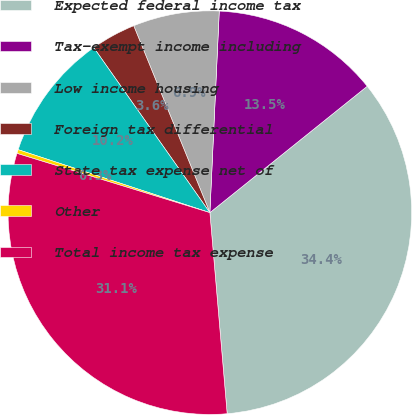<chart> <loc_0><loc_0><loc_500><loc_500><pie_chart><fcel>Expected federal income tax<fcel>Tax-exempt income including<fcel>Low income housing<fcel>Foreign tax differential<fcel>State tax expense net of<fcel>Other<fcel>Total income tax expense<nl><fcel>34.41%<fcel>13.49%<fcel>6.9%<fcel>3.6%<fcel>10.19%<fcel>0.31%<fcel>31.11%<nl></chart> 